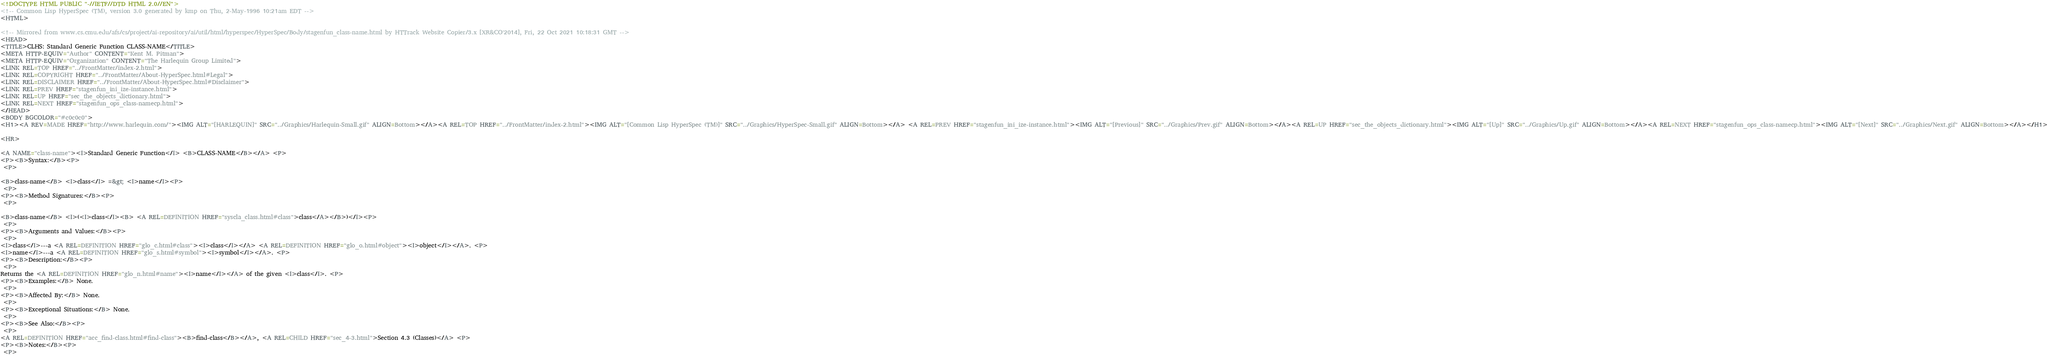<code> <loc_0><loc_0><loc_500><loc_500><_HTML_><!DOCTYPE HTML PUBLIC "-//IETF//DTD HTML 2.0//EN">
<!-- Common Lisp HyperSpec (TM), version 3.0 generated by kmp on Thu, 2-May-1996 10:21am EDT -->
<HTML>

<!-- Mirrored from www.cs.cmu.edu/afs/cs/project/ai-repository/ai/util/html/hyperspec/HyperSpec/Body/stagenfun_class-name.html by HTTrack Website Copier/3.x [XR&CO'2014], Fri, 22 Oct 2021 10:18:31 GMT -->
<HEAD>
<TITLE>CLHS: Standard Generic Function CLASS-NAME</TITLE>
<META HTTP-EQUIV="Author" CONTENT="Kent M. Pitman">
<META HTTP-EQUIV="Organization" CONTENT="The Harlequin Group Limited">
<LINK REL=TOP HREF="../FrontMatter/index-2.html">
<LINK REL=COPYRIGHT HREF="../FrontMatter/About-HyperSpec.html#Legal">
<LINK REL=DISCLAIMER HREF="../FrontMatter/About-HyperSpec.html#Disclaimer">
<LINK REL=PREV HREF="stagenfun_ini_ize-instance.html">
<LINK REL=UP HREF="sec_the_objects_dictionary.html">
<LINK REL=NEXT HREF="stagenfun_ops_class-namecp.html">
</HEAD>
<BODY BGCOLOR="#c0c0c0">
<H1><A REV=MADE HREF="http://www.harlequin.com/"><IMG ALT="[HARLEQUIN]" SRC="../Graphics/Harlequin-Small.gif" ALIGN=Bottom></A><A REL=TOP HREF="../FrontMatter/index-2.html"><IMG ALT="[Common Lisp HyperSpec (TM)]" SRC="../Graphics/HyperSpec-Small.gif" ALIGN=Bottom></A> <A REL=PREV HREF="stagenfun_ini_ize-instance.html"><IMG ALT="[Previous]" SRC="../Graphics/Prev.gif" ALIGN=Bottom></A><A REL=UP HREF="sec_the_objects_dictionary.html"><IMG ALT="[Up]" SRC="../Graphics/Up.gif" ALIGN=Bottom></A><A REL=NEXT HREF="stagenfun_ops_class-namecp.html"><IMG ALT="[Next]" SRC="../Graphics/Next.gif" ALIGN=Bottom></A></H1>

<HR>

<A NAME="class-name"><I>Standard Generic Function</I> <B>CLASS-NAME</B></A> <P>
<P><B>Syntax:</B><P>
 <P>

<B>class-name</B> <I>class</I> =&gt; <I>name</I><P>
 <P>
<P><B>Method Signatures:</B><P>
 <P>

<B>class-name</B> <I>(<I>class</I><B> <A REL=DEFINITION HREF="syscla_class.html#class">class</A></B>)</I><P>
 <P>
<P><B>Arguments and Values:</B><P>
 <P>
<I>class</I>---a <A REL=DEFINITION HREF="glo_c.html#class"><I>class</I></A> <A REL=DEFINITION HREF="glo_o.html#object"><I>object</I></A>. <P>
<I>name</I>---a <A REL=DEFINITION HREF="glo_s.html#symbol"><I>symbol</I></A>. <P>
<P><B>Description:</B><P>
 <P>
Returns the <A REL=DEFINITION HREF="glo_n.html#name"><I>name</I></A> of the given <I>class</I>. <P>
<P><B>Examples:</B> None.
 <P>
<P><B>Affected By:</B> None.
 <P>
<P><B>Exceptional Situations:</B> None.
 <P>
<P><B>See Also:</B><P>
 <P>
<A REL=DEFINITION HREF="acc_find-class.html#find-class"><B>find-class</B></A>, <A REL=CHILD HREF="sec_4-3.html">Section 4.3 (Classes)</A> <P>
<P><B>Notes:</B><P>
 <P></code> 